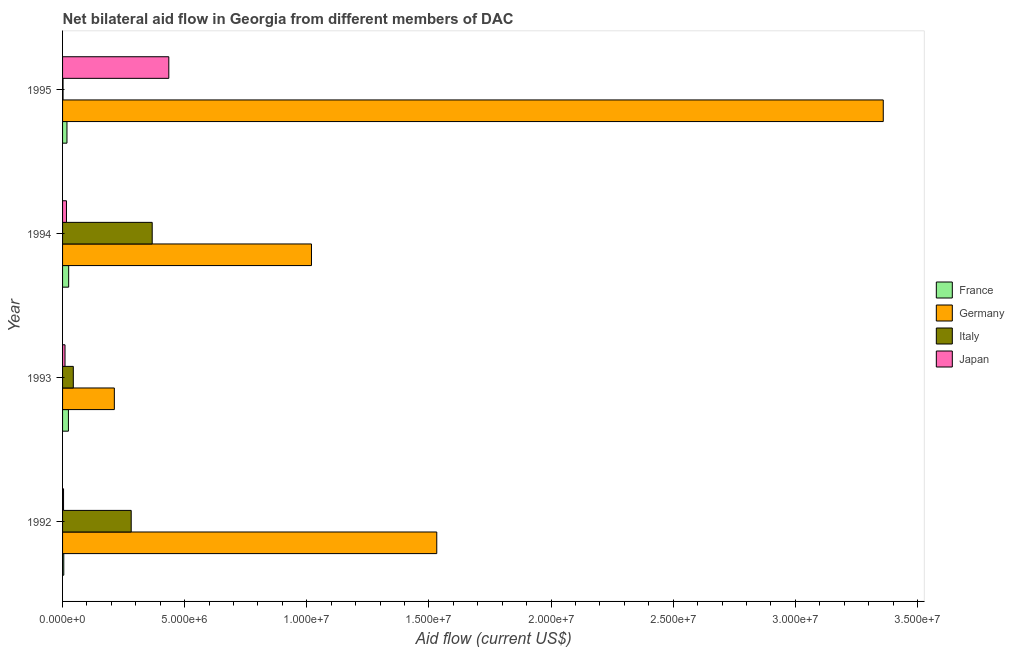Are the number of bars per tick equal to the number of legend labels?
Offer a terse response. Yes. Are the number of bars on each tick of the Y-axis equal?
Your response must be concise. Yes. What is the amount of aid given by france in 1993?
Make the answer very short. 2.40e+05. Across all years, what is the maximum amount of aid given by japan?
Your response must be concise. 4.35e+06. Across all years, what is the minimum amount of aid given by italy?
Provide a short and direct response. 2.00e+04. In which year was the amount of aid given by france maximum?
Your answer should be compact. 1994. What is the total amount of aid given by france in the graph?
Your response must be concise. 7.20e+05. What is the difference between the amount of aid given by france in 1994 and that in 1995?
Make the answer very short. 7.00e+04. What is the difference between the amount of aid given by italy in 1994 and the amount of aid given by japan in 1995?
Provide a succinct answer. -6.80e+05. What is the average amount of aid given by italy per year?
Your answer should be compact. 1.74e+06. In the year 1995, what is the difference between the amount of aid given by italy and amount of aid given by germany?
Provide a short and direct response. -3.36e+07. Is the amount of aid given by germany in 1994 less than that in 1995?
Your response must be concise. Yes. What is the difference between the highest and the second highest amount of aid given by japan?
Make the answer very short. 4.19e+06. What is the difference between the highest and the lowest amount of aid given by germany?
Keep it short and to the point. 3.15e+07. Is it the case that in every year, the sum of the amount of aid given by germany and amount of aid given by italy is greater than the sum of amount of aid given by france and amount of aid given by japan?
Provide a short and direct response. Yes. What does the 2nd bar from the top in 1995 represents?
Offer a terse response. Italy. What does the 2nd bar from the bottom in 1993 represents?
Provide a short and direct response. Germany. Is it the case that in every year, the sum of the amount of aid given by france and amount of aid given by germany is greater than the amount of aid given by italy?
Your response must be concise. Yes. How many bars are there?
Your answer should be compact. 16. Are all the bars in the graph horizontal?
Ensure brevity in your answer.  Yes. What is the difference between two consecutive major ticks on the X-axis?
Give a very brief answer. 5.00e+06. Are the values on the major ticks of X-axis written in scientific E-notation?
Your answer should be very brief. Yes. Does the graph contain grids?
Provide a succinct answer. No. How are the legend labels stacked?
Offer a very short reply. Vertical. What is the title of the graph?
Your answer should be compact. Net bilateral aid flow in Georgia from different members of DAC. Does "Sweden" appear as one of the legend labels in the graph?
Your answer should be very brief. No. What is the label or title of the Y-axis?
Your answer should be very brief. Year. What is the Aid flow (current US$) of Germany in 1992?
Ensure brevity in your answer.  1.53e+07. What is the Aid flow (current US$) in Italy in 1992?
Keep it short and to the point. 2.81e+06. What is the Aid flow (current US$) in Japan in 1992?
Your answer should be very brief. 4.00e+04. What is the Aid flow (current US$) in Germany in 1993?
Your answer should be very brief. 2.12e+06. What is the Aid flow (current US$) in Italy in 1993?
Offer a very short reply. 4.40e+05. What is the Aid flow (current US$) in France in 1994?
Your response must be concise. 2.50e+05. What is the Aid flow (current US$) of Germany in 1994?
Offer a terse response. 1.02e+07. What is the Aid flow (current US$) in Italy in 1994?
Provide a succinct answer. 3.67e+06. What is the Aid flow (current US$) in Germany in 1995?
Ensure brevity in your answer.  3.36e+07. What is the Aid flow (current US$) in Italy in 1995?
Keep it short and to the point. 2.00e+04. What is the Aid flow (current US$) of Japan in 1995?
Keep it short and to the point. 4.35e+06. Across all years, what is the maximum Aid flow (current US$) of France?
Provide a short and direct response. 2.50e+05. Across all years, what is the maximum Aid flow (current US$) of Germany?
Your answer should be very brief. 3.36e+07. Across all years, what is the maximum Aid flow (current US$) in Italy?
Offer a very short reply. 3.67e+06. Across all years, what is the maximum Aid flow (current US$) of Japan?
Your response must be concise. 4.35e+06. Across all years, what is the minimum Aid flow (current US$) of France?
Keep it short and to the point. 5.00e+04. Across all years, what is the minimum Aid flow (current US$) in Germany?
Keep it short and to the point. 2.12e+06. Across all years, what is the minimum Aid flow (current US$) of Japan?
Make the answer very short. 4.00e+04. What is the total Aid flow (current US$) of France in the graph?
Ensure brevity in your answer.  7.20e+05. What is the total Aid flow (current US$) in Germany in the graph?
Provide a short and direct response. 6.12e+07. What is the total Aid flow (current US$) in Italy in the graph?
Offer a very short reply. 6.94e+06. What is the total Aid flow (current US$) in Japan in the graph?
Give a very brief answer. 4.65e+06. What is the difference between the Aid flow (current US$) of Germany in 1992 and that in 1993?
Offer a terse response. 1.32e+07. What is the difference between the Aid flow (current US$) in Italy in 1992 and that in 1993?
Ensure brevity in your answer.  2.37e+06. What is the difference between the Aid flow (current US$) in Japan in 1992 and that in 1993?
Ensure brevity in your answer.  -6.00e+04. What is the difference between the Aid flow (current US$) in Germany in 1992 and that in 1994?
Make the answer very short. 5.13e+06. What is the difference between the Aid flow (current US$) in Italy in 1992 and that in 1994?
Ensure brevity in your answer.  -8.60e+05. What is the difference between the Aid flow (current US$) of Japan in 1992 and that in 1994?
Your answer should be very brief. -1.20e+05. What is the difference between the Aid flow (current US$) of Germany in 1992 and that in 1995?
Your response must be concise. -1.83e+07. What is the difference between the Aid flow (current US$) of Italy in 1992 and that in 1995?
Your response must be concise. 2.79e+06. What is the difference between the Aid flow (current US$) in Japan in 1992 and that in 1995?
Give a very brief answer. -4.31e+06. What is the difference between the Aid flow (current US$) of France in 1993 and that in 1994?
Offer a terse response. -10000. What is the difference between the Aid flow (current US$) of Germany in 1993 and that in 1994?
Ensure brevity in your answer.  -8.07e+06. What is the difference between the Aid flow (current US$) in Italy in 1993 and that in 1994?
Your answer should be very brief. -3.23e+06. What is the difference between the Aid flow (current US$) of Japan in 1993 and that in 1994?
Offer a terse response. -6.00e+04. What is the difference between the Aid flow (current US$) of Germany in 1993 and that in 1995?
Your response must be concise. -3.15e+07. What is the difference between the Aid flow (current US$) of Japan in 1993 and that in 1995?
Your answer should be very brief. -4.25e+06. What is the difference between the Aid flow (current US$) in Germany in 1994 and that in 1995?
Ensure brevity in your answer.  -2.34e+07. What is the difference between the Aid flow (current US$) in Italy in 1994 and that in 1995?
Make the answer very short. 3.65e+06. What is the difference between the Aid flow (current US$) of Japan in 1994 and that in 1995?
Your response must be concise. -4.19e+06. What is the difference between the Aid flow (current US$) of France in 1992 and the Aid flow (current US$) of Germany in 1993?
Your response must be concise. -2.07e+06. What is the difference between the Aid flow (current US$) in France in 1992 and the Aid flow (current US$) in Italy in 1993?
Give a very brief answer. -3.90e+05. What is the difference between the Aid flow (current US$) of Germany in 1992 and the Aid flow (current US$) of Italy in 1993?
Your response must be concise. 1.49e+07. What is the difference between the Aid flow (current US$) in Germany in 1992 and the Aid flow (current US$) in Japan in 1993?
Offer a terse response. 1.52e+07. What is the difference between the Aid flow (current US$) in Italy in 1992 and the Aid flow (current US$) in Japan in 1993?
Provide a succinct answer. 2.71e+06. What is the difference between the Aid flow (current US$) in France in 1992 and the Aid flow (current US$) in Germany in 1994?
Your answer should be compact. -1.01e+07. What is the difference between the Aid flow (current US$) in France in 1992 and the Aid flow (current US$) in Italy in 1994?
Your answer should be very brief. -3.62e+06. What is the difference between the Aid flow (current US$) of Germany in 1992 and the Aid flow (current US$) of Italy in 1994?
Give a very brief answer. 1.16e+07. What is the difference between the Aid flow (current US$) in Germany in 1992 and the Aid flow (current US$) in Japan in 1994?
Your answer should be compact. 1.52e+07. What is the difference between the Aid flow (current US$) of Italy in 1992 and the Aid flow (current US$) of Japan in 1994?
Offer a terse response. 2.65e+06. What is the difference between the Aid flow (current US$) of France in 1992 and the Aid flow (current US$) of Germany in 1995?
Provide a succinct answer. -3.36e+07. What is the difference between the Aid flow (current US$) of France in 1992 and the Aid flow (current US$) of Italy in 1995?
Your answer should be very brief. 3.00e+04. What is the difference between the Aid flow (current US$) of France in 1992 and the Aid flow (current US$) of Japan in 1995?
Your response must be concise. -4.30e+06. What is the difference between the Aid flow (current US$) of Germany in 1992 and the Aid flow (current US$) of Italy in 1995?
Keep it short and to the point. 1.53e+07. What is the difference between the Aid flow (current US$) in Germany in 1992 and the Aid flow (current US$) in Japan in 1995?
Give a very brief answer. 1.10e+07. What is the difference between the Aid flow (current US$) in Italy in 1992 and the Aid flow (current US$) in Japan in 1995?
Make the answer very short. -1.54e+06. What is the difference between the Aid flow (current US$) in France in 1993 and the Aid flow (current US$) in Germany in 1994?
Your answer should be very brief. -9.95e+06. What is the difference between the Aid flow (current US$) of France in 1993 and the Aid flow (current US$) of Italy in 1994?
Offer a terse response. -3.43e+06. What is the difference between the Aid flow (current US$) of Germany in 1993 and the Aid flow (current US$) of Italy in 1994?
Your answer should be very brief. -1.55e+06. What is the difference between the Aid flow (current US$) of Germany in 1993 and the Aid flow (current US$) of Japan in 1994?
Make the answer very short. 1.96e+06. What is the difference between the Aid flow (current US$) of France in 1993 and the Aid flow (current US$) of Germany in 1995?
Provide a succinct answer. -3.34e+07. What is the difference between the Aid flow (current US$) of France in 1993 and the Aid flow (current US$) of Italy in 1995?
Your answer should be very brief. 2.20e+05. What is the difference between the Aid flow (current US$) in France in 1993 and the Aid flow (current US$) in Japan in 1995?
Provide a short and direct response. -4.11e+06. What is the difference between the Aid flow (current US$) of Germany in 1993 and the Aid flow (current US$) of Italy in 1995?
Keep it short and to the point. 2.10e+06. What is the difference between the Aid flow (current US$) in Germany in 1993 and the Aid flow (current US$) in Japan in 1995?
Offer a very short reply. -2.23e+06. What is the difference between the Aid flow (current US$) in Italy in 1993 and the Aid flow (current US$) in Japan in 1995?
Provide a succinct answer. -3.91e+06. What is the difference between the Aid flow (current US$) in France in 1994 and the Aid flow (current US$) in Germany in 1995?
Offer a very short reply. -3.34e+07. What is the difference between the Aid flow (current US$) in France in 1994 and the Aid flow (current US$) in Japan in 1995?
Offer a terse response. -4.10e+06. What is the difference between the Aid flow (current US$) of Germany in 1994 and the Aid flow (current US$) of Italy in 1995?
Your answer should be very brief. 1.02e+07. What is the difference between the Aid flow (current US$) in Germany in 1994 and the Aid flow (current US$) in Japan in 1995?
Your response must be concise. 5.84e+06. What is the difference between the Aid flow (current US$) in Italy in 1994 and the Aid flow (current US$) in Japan in 1995?
Offer a very short reply. -6.80e+05. What is the average Aid flow (current US$) of Germany per year?
Ensure brevity in your answer.  1.53e+07. What is the average Aid flow (current US$) of Italy per year?
Give a very brief answer. 1.74e+06. What is the average Aid flow (current US$) in Japan per year?
Provide a succinct answer. 1.16e+06. In the year 1992, what is the difference between the Aid flow (current US$) of France and Aid flow (current US$) of Germany?
Your response must be concise. -1.53e+07. In the year 1992, what is the difference between the Aid flow (current US$) of France and Aid flow (current US$) of Italy?
Make the answer very short. -2.76e+06. In the year 1992, what is the difference between the Aid flow (current US$) in Germany and Aid flow (current US$) in Italy?
Make the answer very short. 1.25e+07. In the year 1992, what is the difference between the Aid flow (current US$) in Germany and Aid flow (current US$) in Japan?
Keep it short and to the point. 1.53e+07. In the year 1992, what is the difference between the Aid flow (current US$) in Italy and Aid flow (current US$) in Japan?
Make the answer very short. 2.77e+06. In the year 1993, what is the difference between the Aid flow (current US$) of France and Aid flow (current US$) of Germany?
Provide a short and direct response. -1.88e+06. In the year 1993, what is the difference between the Aid flow (current US$) in France and Aid flow (current US$) in Italy?
Give a very brief answer. -2.00e+05. In the year 1993, what is the difference between the Aid flow (current US$) of France and Aid flow (current US$) of Japan?
Keep it short and to the point. 1.40e+05. In the year 1993, what is the difference between the Aid flow (current US$) of Germany and Aid flow (current US$) of Italy?
Provide a short and direct response. 1.68e+06. In the year 1993, what is the difference between the Aid flow (current US$) of Germany and Aid flow (current US$) of Japan?
Offer a very short reply. 2.02e+06. In the year 1994, what is the difference between the Aid flow (current US$) in France and Aid flow (current US$) in Germany?
Your answer should be very brief. -9.94e+06. In the year 1994, what is the difference between the Aid flow (current US$) of France and Aid flow (current US$) of Italy?
Your answer should be very brief. -3.42e+06. In the year 1994, what is the difference between the Aid flow (current US$) of Germany and Aid flow (current US$) of Italy?
Ensure brevity in your answer.  6.52e+06. In the year 1994, what is the difference between the Aid flow (current US$) in Germany and Aid flow (current US$) in Japan?
Provide a short and direct response. 1.00e+07. In the year 1994, what is the difference between the Aid flow (current US$) in Italy and Aid flow (current US$) in Japan?
Your response must be concise. 3.51e+06. In the year 1995, what is the difference between the Aid flow (current US$) of France and Aid flow (current US$) of Germany?
Make the answer very short. -3.34e+07. In the year 1995, what is the difference between the Aid flow (current US$) of France and Aid flow (current US$) of Japan?
Provide a short and direct response. -4.17e+06. In the year 1995, what is the difference between the Aid flow (current US$) of Germany and Aid flow (current US$) of Italy?
Offer a very short reply. 3.36e+07. In the year 1995, what is the difference between the Aid flow (current US$) of Germany and Aid flow (current US$) of Japan?
Give a very brief answer. 2.92e+07. In the year 1995, what is the difference between the Aid flow (current US$) of Italy and Aid flow (current US$) of Japan?
Ensure brevity in your answer.  -4.33e+06. What is the ratio of the Aid flow (current US$) of France in 1992 to that in 1993?
Give a very brief answer. 0.21. What is the ratio of the Aid flow (current US$) of Germany in 1992 to that in 1993?
Provide a short and direct response. 7.23. What is the ratio of the Aid flow (current US$) of Italy in 1992 to that in 1993?
Offer a terse response. 6.39. What is the ratio of the Aid flow (current US$) in Japan in 1992 to that in 1993?
Ensure brevity in your answer.  0.4. What is the ratio of the Aid flow (current US$) in France in 1992 to that in 1994?
Keep it short and to the point. 0.2. What is the ratio of the Aid flow (current US$) in Germany in 1992 to that in 1994?
Give a very brief answer. 1.5. What is the ratio of the Aid flow (current US$) in Italy in 1992 to that in 1994?
Ensure brevity in your answer.  0.77. What is the ratio of the Aid flow (current US$) in France in 1992 to that in 1995?
Provide a succinct answer. 0.28. What is the ratio of the Aid flow (current US$) of Germany in 1992 to that in 1995?
Offer a terse response. 0.46. What is the ratio of the Aid flow (current US$) of Italy in 1992 to that in 1995?
Your answer should be very brief. 140.5. What is the ratio of the Aid flow (current US$) in Japan in 1992 to that in 1995?
Give a very brief answer. 0.01. What is the ratio of the Aid flow (current US$) in Germany in 1993 to that in 1994?
Give a very brief answer. 0.21. What is the ratio of the Aid flow (current US$) in Italy in 1993 to that in 1994?
Ensure brevity in your answer.  0.12. What is the ratio of the Aid flow (current US$) of France in 1993 to that in 1995?
Offer a terse response. 1.33. What is the ratio of the Aid flow (current US$) in Germany in 1993 to that in 1995?
Give a very brief answer. 0.06. What is the ratio of the Aid flow (current US$) in Italy in 1993 to that in 1995?
Provide a short and direct response. 22. What is the ratio of the Aid flow (current US$) of Japan in 1993 to that in 1995?
Ensure brevity in your answer.  0.02. What is the ratio of the Aid flow (current US$) in France in 1994 to that in 1995?
Your answer should be very brief. 1.39. What is the ratio of the Aid flow (current US$) in Germany in 1994 to that in 1995?
Make the answer very short. 0.3. What is the ratio of the Aid flow (current US$) of Italy in 1994 to that in 1995?
Your response must be concise. 183.5. What is the ratio of the Aid flow (current US$) in Japan in 1994 to that in 1995?
Offer a very short reply. 0.04. What is the difference between the highest and the second highest Aid flow (current US$) of Germany?
Keep it short and to the point. 1.83e+07. What is the difference between the highest and the second highest Aid flow (current US$) of Italy?
Your answer should be compact. 8.60e+05. What is the difference between the highest and the second highest Aid flow (current US$) of Japan?
Give a very brief answer. 4.19e+06. What is the difference between the highest and the lowest Aid flow (current US$) of Germany?
Offer a very short reply. 3.15e+07. What is the difference between the highest and the lowest Aid flow (current US$) in Italy?
Offer a very short reply. 3.65e+06. What is the difference between the highest and the lowest Aid flow (current US$) of Japan?
Your response must be concise. 4.31e+06. 